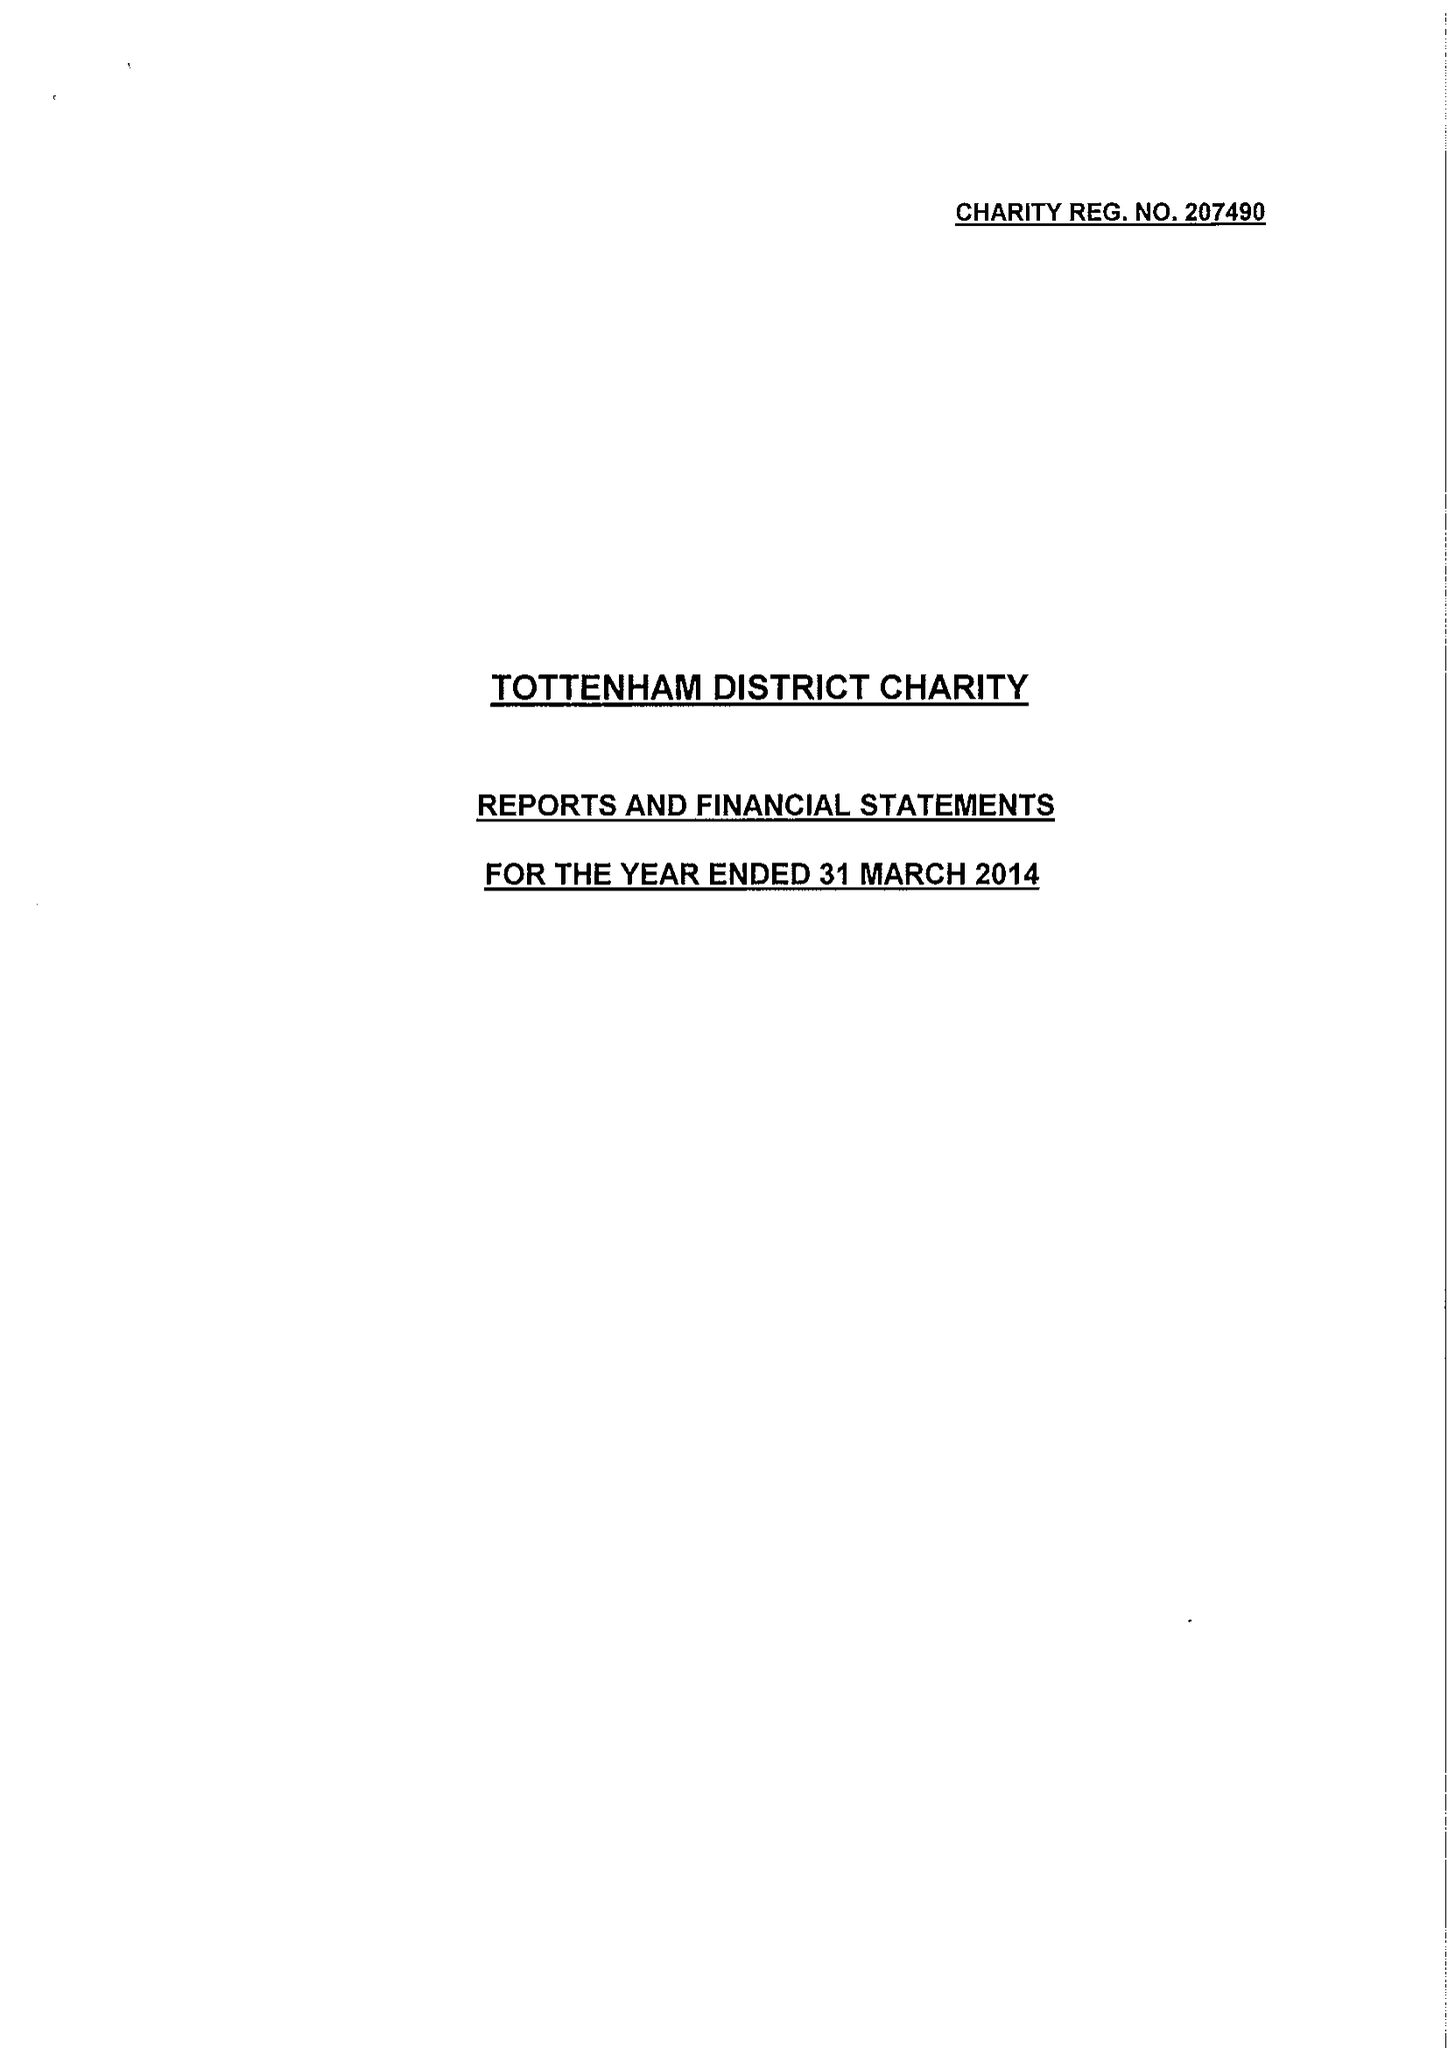What is the value for the spending_annually_in_british_pounds?
Answer the question using a single word or phrase. 92937.00 